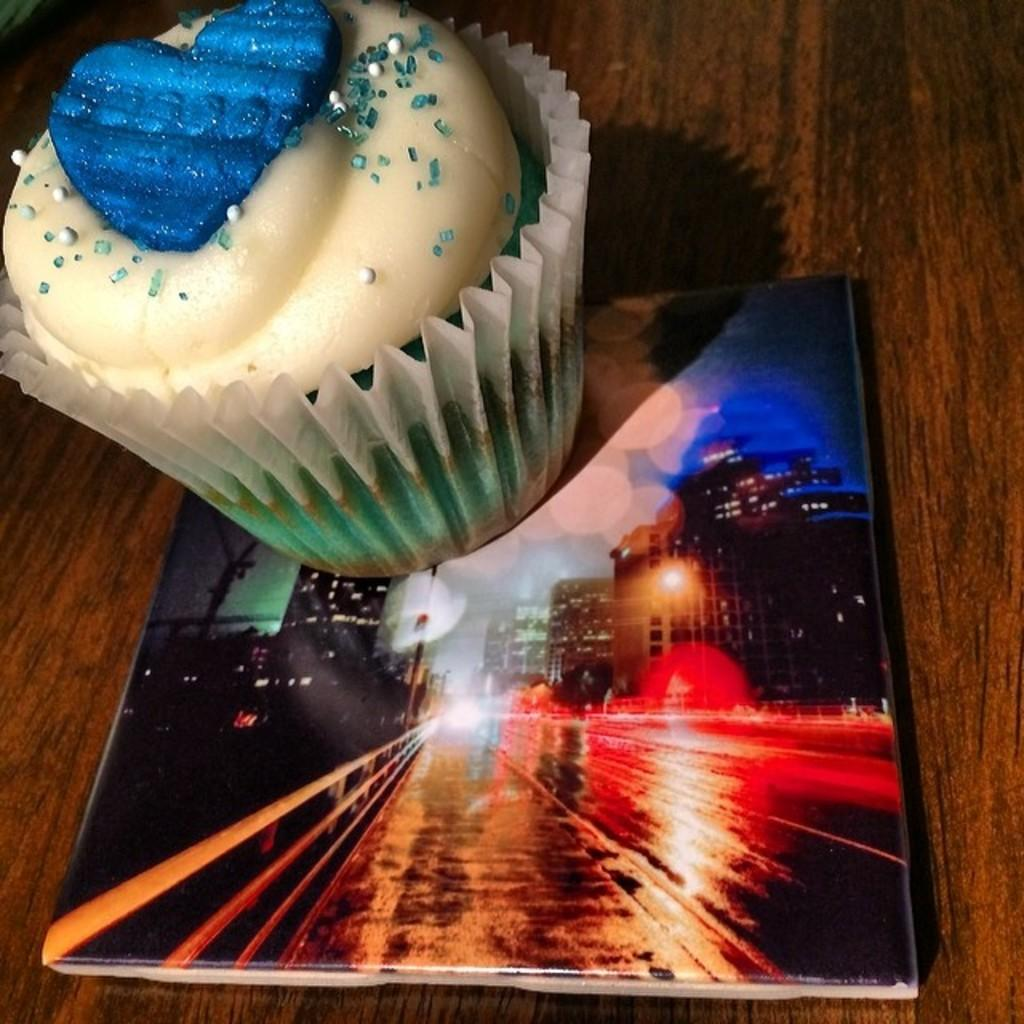What type of food is shown in the image? There is a muffin with cream and toppings in the image. What else is present in the image besides the muffin? There is a paper cup in the image. Where are the muffin and paper cup placed? They are on a book. What can be seen in the background of the image? Buildings, roads, and lights are visible in the image. What is the surface on which the book is placed? The book is placed on a wooden surface. Can you see a ship sailing in the background of the image? No, there is no ship visible in the image. Is there a giraffe standing next to the muffin in the image? No, there is no giraffe present in the image. 